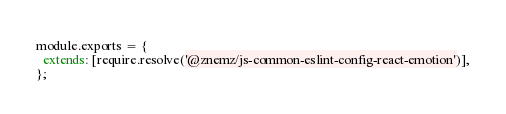Convert code to text. <code><loc_0><loc_0><loc_500><loc_500><_JavaScript_>module.exports = {
  extends: [require.resolve('@znemz/js-common-eslint-config-react-emotion')],
};
</code> 